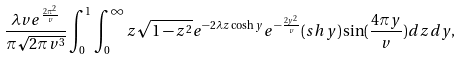<formula> <loc_0><loc_0><loc_500><loc_500>\frac { \lambda v e ^ { \frac { 2 \pi ^ { 2 } } { v } } } { \pi \sqrt { 2 \pi v ^ { 3 } } } \int _ { 0 } ^ { 1 } \int _ { 0 } ^ { \infty } z \sqrt { 1 - z ^ { 2 } } e ^ { - 2 \lambda z \cosh y } e ^ { - \frac { 2 y ^ { 2 } } { v } } ( s h y ) \sin ( \frac { 4 \pi y } { v } ) d z d y ,</formula> 